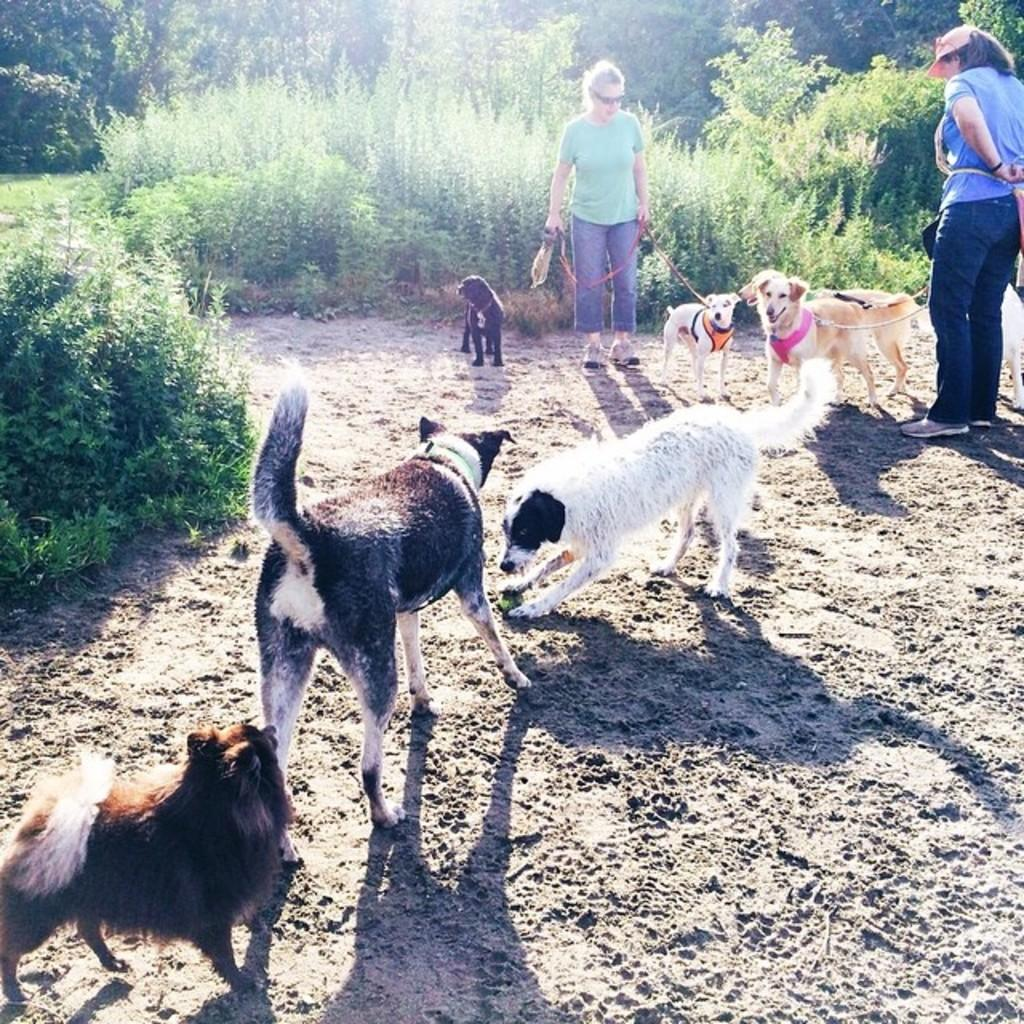What type of animals are present in the image? There are dogs in the image. Who else is present in the image besides the dogs? There are women in the image. How are the dogs interacting with the women? Some dogs are being held by the women. What type of natural environment can be seen in the image? There are trees in the image. What type of wristwatch is the dog wearing in the image? There are no wristwatches present in the image, and dogs do not wear wristwatches. What button is the woman pressing on the dog in the image? There are no buttons being pressed on the dogs in the image. 